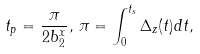Convert formula to latex. <formula><loc_0><loc_0><loc_500><loc_500>t _ { p } = \frac { \pi } { 2 b _ { 2 } ^ { x } } , \, \pi = \int _ { 0 } ^ { t _ { s } } \Delta _ { z } ( t ) d t ,</formula> 